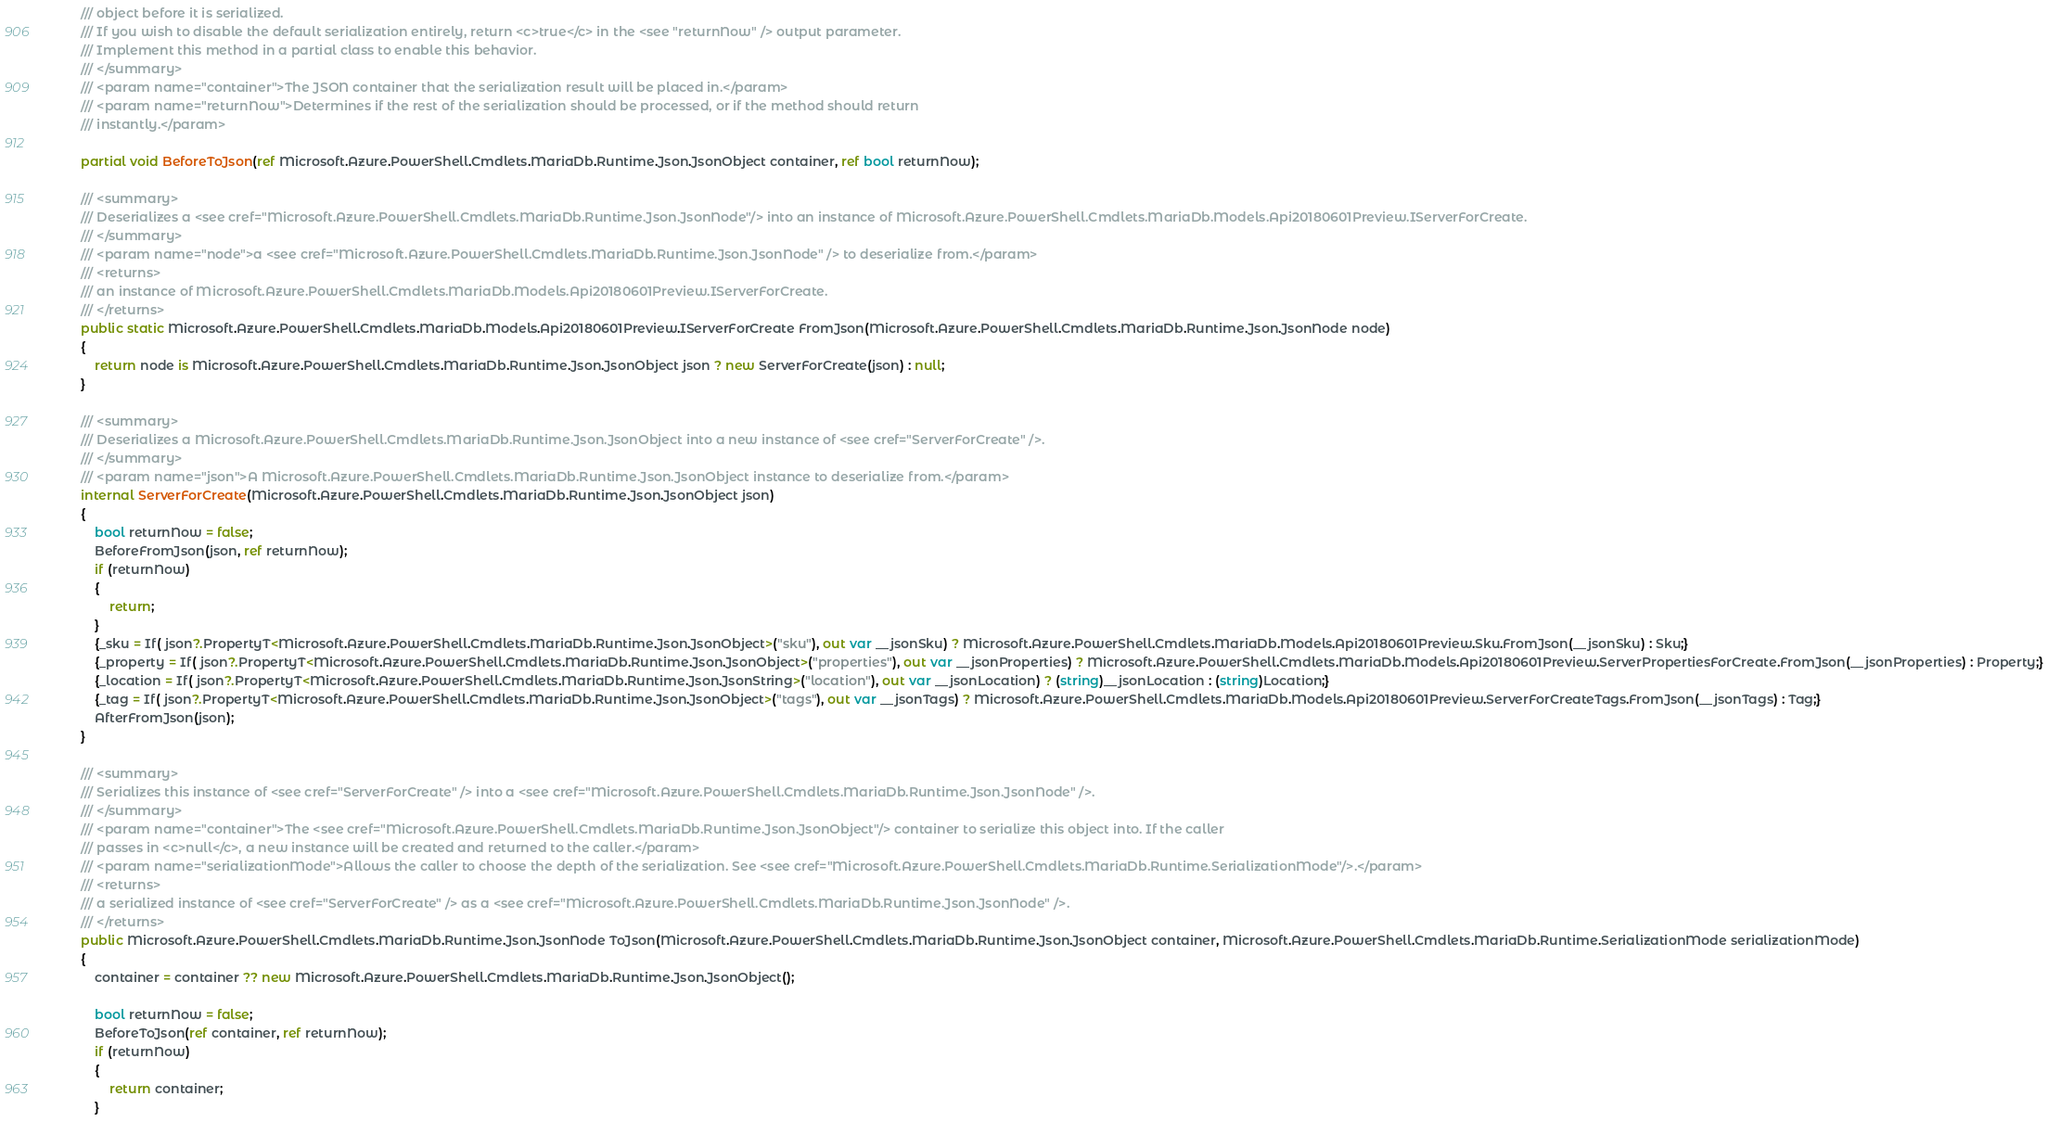<code> <loc_0><loc_0><loc_500><loc_500><_C#_>        /// object before it is serialized.
        /// If you wish to disable the default serialization entirely, return <c>true</c> in the <see "returnNow" /> output parameter.
        /// Implement this method in a partial class to enable this behavior.
        /// </summary>
        /// <param name="container">The JSON container that the serialization result will be placed in.</param>
        /// <param name="returnNow">Determines if the rest of the serialization should be processed, or if the method should return
        /// instantly.</param>

        partial void BeforeToJson(ref Microsoft.Azure.PowerShell.Cmdlets.MariaDb.Runtime.Json.JsonObject container, ref bool returnNow);

        /// <summary>
        /// Deserializes a <see cref="Microsoft.Azure.PowerShell.Cmdlets.MariaDb.Runtime.Json.JsonNode"/> into an instance of Microsoft.Azure.PowerShell.Cmdlets.MariaDb.Models.Api20180601Preview.IServerForCreate.
        /// </summary>
        /// <param name="node">a <see cref="Microsoft.Azure.PowerShell.Cmdlets.MariaDb.Runtime.Json.JsonNode" /> to deserialize from.</param>
        /// <returns>
        /// an instance of Microsoft.Azure.PowerShell.Cmdlets.MariaDb.Models.Api20180601Preview.IServerForCreate.
        /// </returns>
        public static Microsoft.Azure.PowerShell.Cmdlets.MariaDb.Models.Api20180601Preview.IServerForCreate FromJson(Microsoft.Azure.PowerShell.Cmdlets.MariaDb.Runtime.Json.JsonNode node)
        {
            return node is Microsoft.Azure.PowerShell.Cmdlets.MariaDb.Runtime.Json.JsonObject json ? new ServerForCreate(json) : null;
        }

        /// <summary>
        /// Deserializes a Microsoft.Azure.PowerShell.Cmdlets.MariaDb.Runtime.Json.JsonObject into a new instance of <see cref="ServerForCreate" />.
        /// </summary>
        /// <param name="json">A Microsoft.Azure.PowerShell.Cmdlets.MariaDb.Runtime.Json.JsonObject instance to deserialize from.</param>
        internal ServerForCreate(Microsoft.Azure.PowerShell.Cmdlets.MariaDb.Runtime.Json.JsonObject json)
        {
            bool returnNow = false;
            BeforeFromJson(json, ref returnNow);
            if (returnNow)
            {
                return;
            }
            {_sku = If( json?.PropertyT<Microsoft.Azure.PowerShell.Cmdlets.MariaDb.Runtime.Json.JsonObject>("sku"), out var __jsonSku) ? Microsoft.Azure.PowerShell.Cmdlets.MariaDb.Models.Api20180601Preview.Sku.FromJson(__jsonSku) : Sku;}
            {_property = If( json?.PropertyT<Microsoft.Azure.PowerShell.Cmdlets.MariaDb.Runtime.Json.JsonObject>("properties"), out var __jsonProperties) ? Microsoft.Azure.PowerShell.Cmdlets.MariaDb.Models.Api20180601Preview.ServerPropertiesForCreate.FromJson(__jsonProperties) : Property;}
            {_location = If( json?.PropertyT<Microsoft.Azure.PowerShell.Cmdlets.MariaDb.Runtime.Json.JsonString>("location"), out var __jsonLocation) ? (string)__jsonLocation : (string)Location;}
            {_tag = If( json?.PropertyT<Microsoft.Azure.PowerShell.Cmdlets.MariaDb.Runtime.Json.JsonObject>("tags"), out var __jsonTags) ? Microsoft.Azure.PowerShell.Cmdlets.MariaDb.Models.Api20180601Preview.ServerForCreateTags.FromJson(__jsonTags) : Tag;}
            AfterFromJson(json);
        }

        /// <summary>
        /// Serializes this instance of <see cref="ServerForCreate" /> into a <see cref="Microsoft.Azure.PowerShell.Cmdlets.MariaDb.Runtime.Json.JsonNode" />.
        /// </summary>
        /// <param name="container">The <see cref="Microsoft.Azure.PowerShell.Cmdlets.MariaDb.Runtime.Json.JsonObject"/> container to serialize this object into. If the caller
        /// passes in <c>null</c>, a new instance will be created and returned to the caller.</param>
        /// <param name="serializationMode">Allows the caller to choose the depth of the serialization. See <see cref="Microsoft.Azure.PowerShell.Cmdlets.MariaDb.Runtime.SerializationMode"/>.</param>
        /// <returns>
        /// a serialized instance of <see cref="ServerForCreate" /> as a <see cref="Microsoft.Azure.PowerShell.Cmdlets.MariaDb.Runtime.Json.JsonNode" />.
        /// </returns>
        public Microsoft.Azure.PowerShell.Cmdlets.MariaDb.Runtime.Json.JsonNode ToJson(Microsoft.Azure.PowerShell.Cmdlets.MariaDb.Runtime.Json.JsonObject container, Microsoft.Azure.PowerShell.Cmdlets.MariaDb.Runtime.SerializationMode serializationMode)
        {
            container = container ?? new Microsoft.Azure.PowerShell.Cmdlets.MariaDb.Runtime.Json.JsonObject();

            bool returnNow = false;
            BeforeToJson(ref container, ref returnNow);
            if (returnNow)
            {
                return container;
            }</code> 